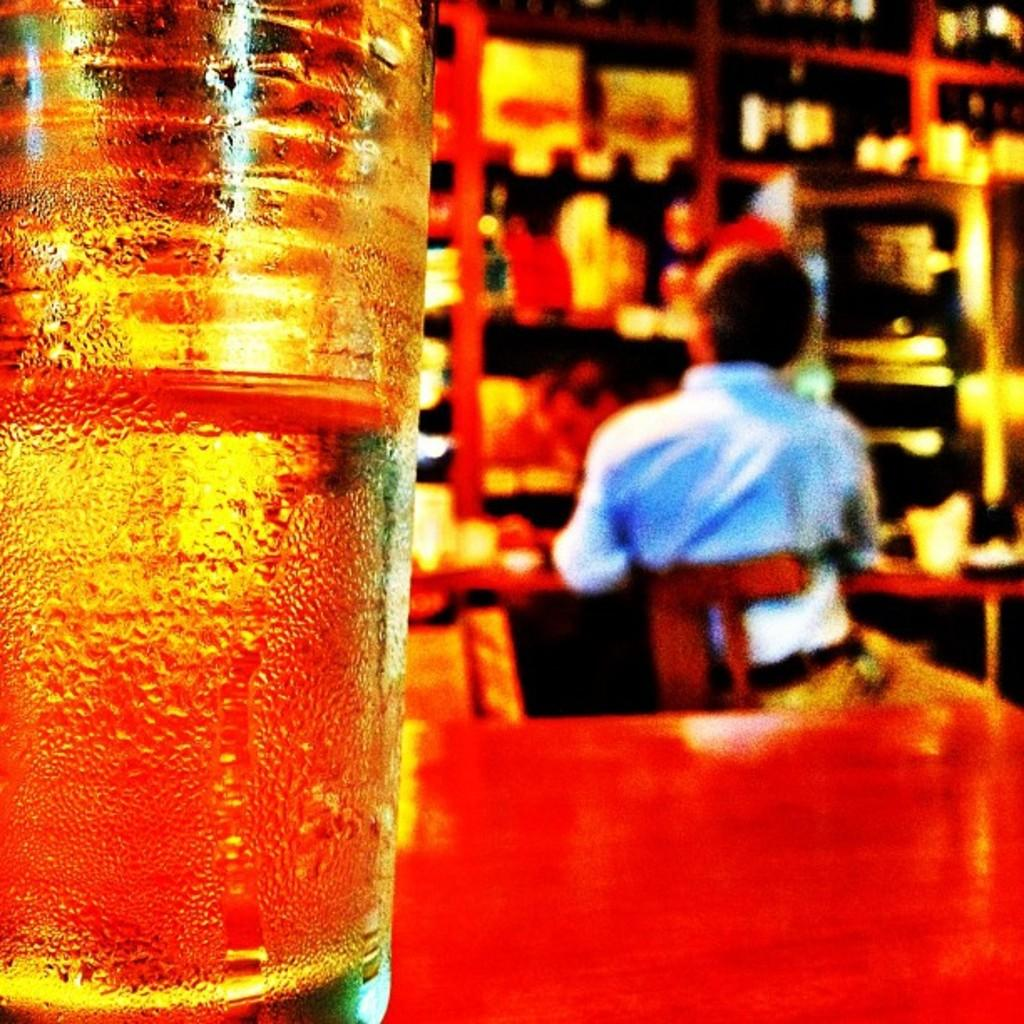What is located on the table in the foreground of the image? There is a glass on a table in the foreground of the image. What can be seen in the background of the image? There is a man sitting on a chair in the background of the image, and he is near a table. What is present on the table in the background of the image? There are objects in a rack in the background of the image. What type of coal is being used to power the engine in the image? There is no coal or engine present in the image. 